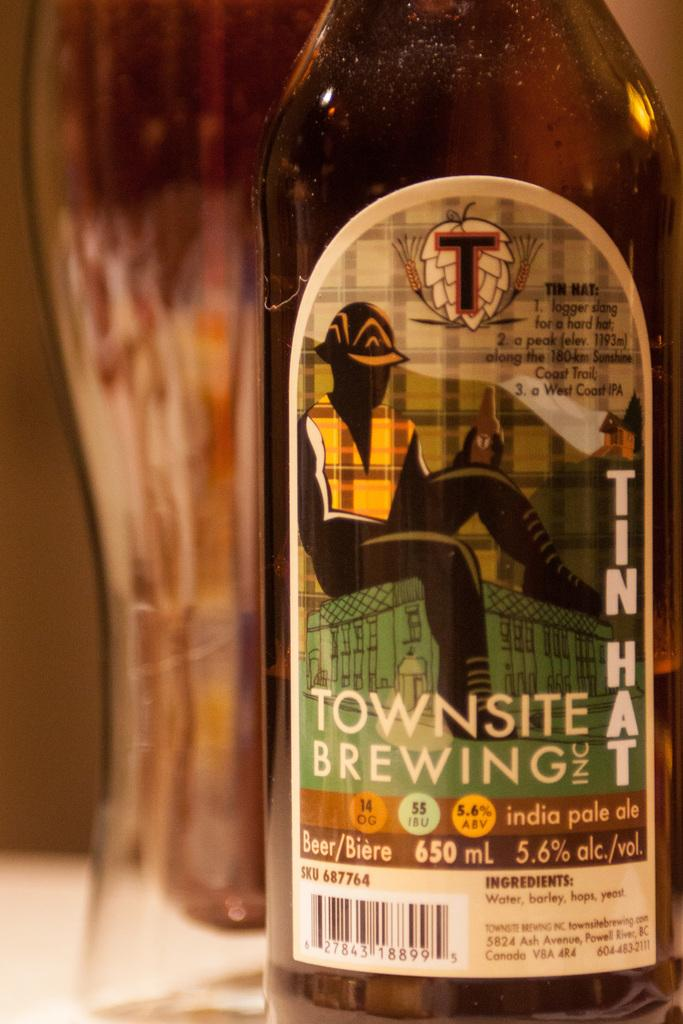What object is present in the image that can contain liquid? There is a bottle present in the image. What can be found on the surface of the bottle? There is a label on the bottle. What type of pan is being used to cook food in the image? There is no pan present in the image; it only features a bottle with a label on it. What type of disease can be seen affecting the horse in the image? There is no horse or disease present in the image; it only features a bottle with a label on it. 